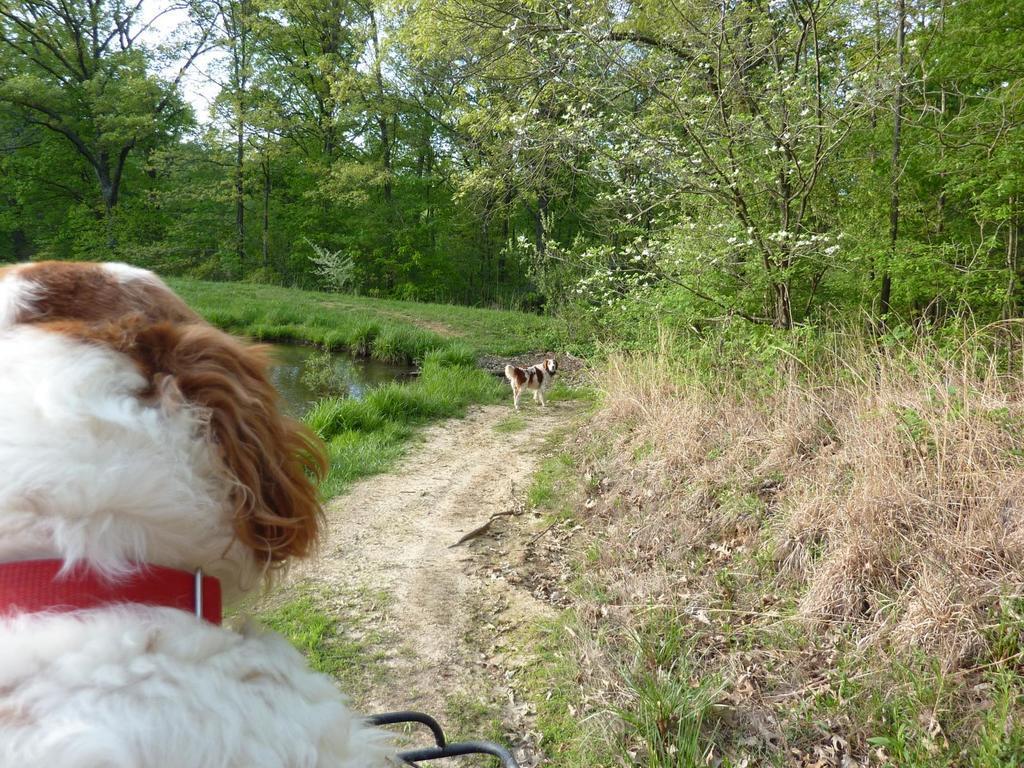How would you summarize this image in a sentence or two? In this image there are two dogs, there is grass,there are plants there are trees, there is a pond. 